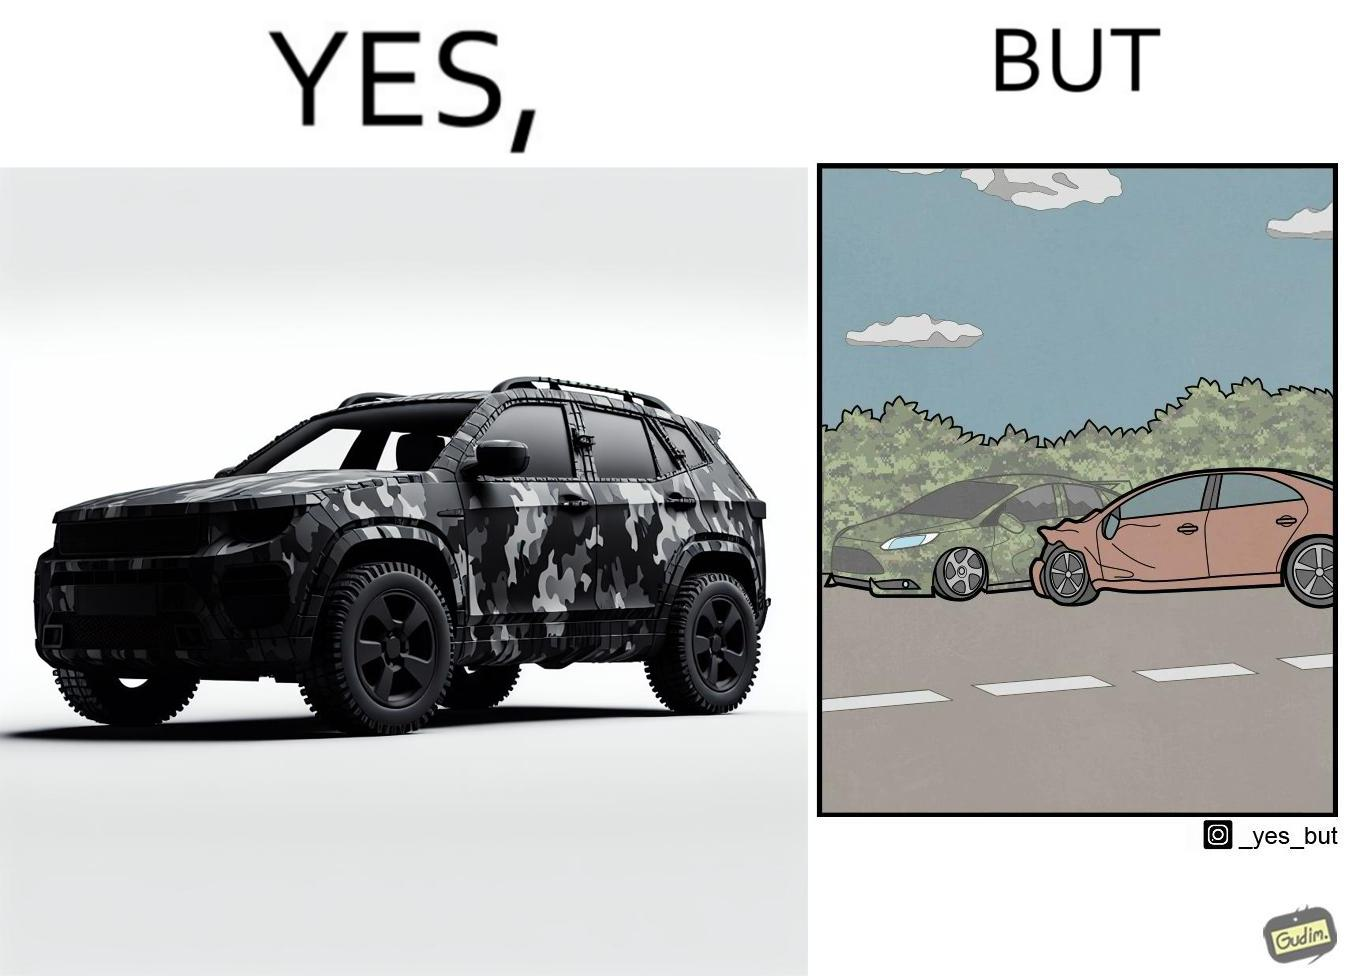What do you see in each half of this image? In the left part of the image: a car painted in a camouflage color In the right part of the image: a red color car crashing into a camouflage color car due to the background of green plants 